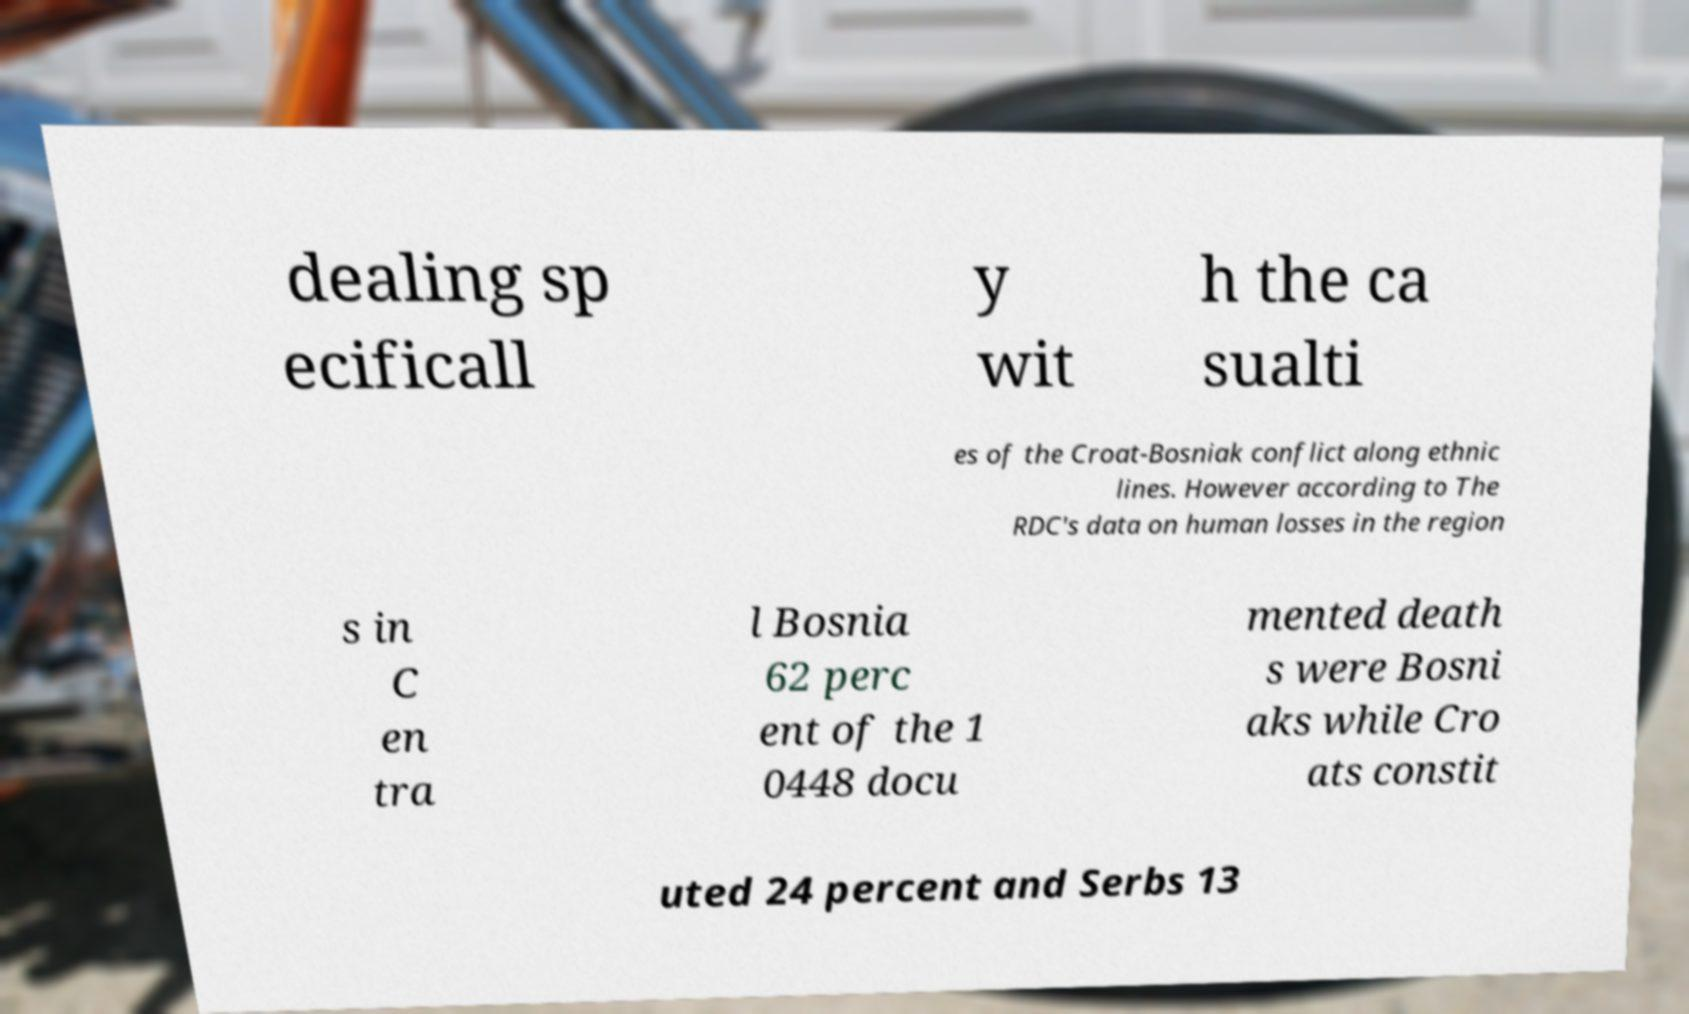Can you read and provide the text displayed in the image?This photo seems to have some interesting text. Can you extract and type it out for me? dealing sp ecificall y wit h the ca sualti es of the Croat-Bosniak conflict along ethnic lines. However according to The RDC's data on human losses in the region s in C en tra l Bosnia 62 perc ent of the 1 0448 docu mented death s were Bosni aks while Cro ats constit uted 24 percent and Serbs 13 